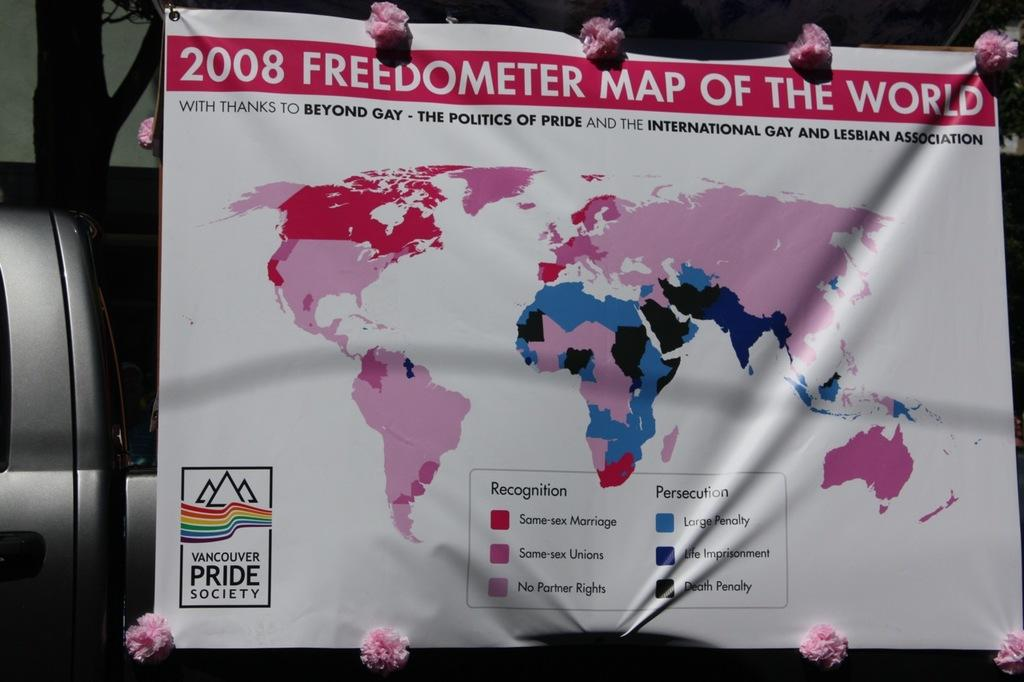<image>
Give a short and clear explanation of the subsequent image. A map of the world with the words freedometer map of the world on the top. 